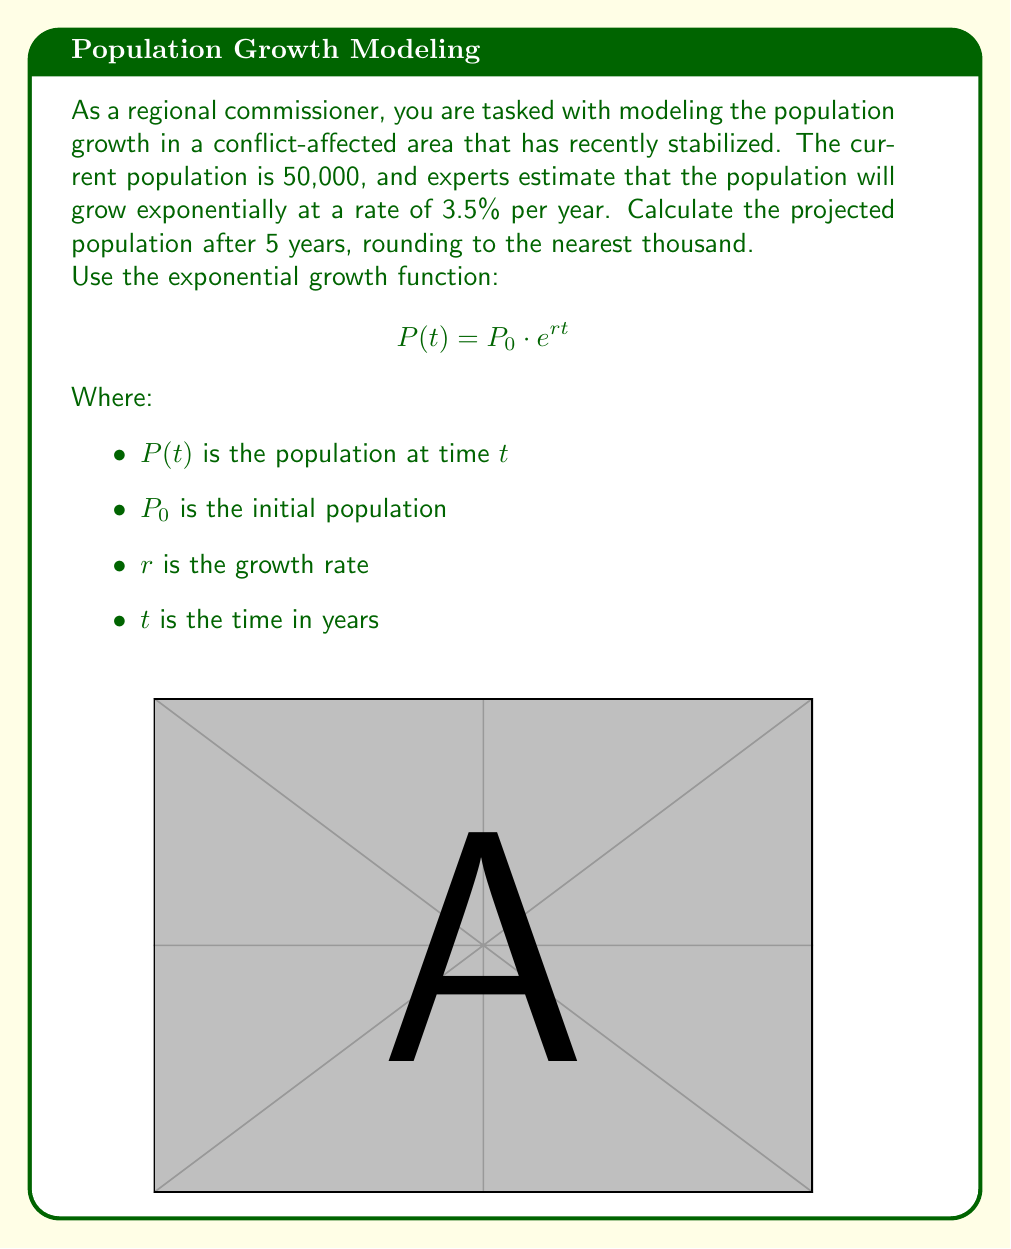Can you solve this math problem? Let's solve this step-by-step:

1) We are given:
   $P_0 = 50,000$ (initial population)
   $r = 3.5\% = 0.035$ (growth rate)
   $t = 5$ years

2) We'll use the exponential growth function:
   $$P(t) = P_0 \cdot e^{rt}$$

3) Substituting our values:
   $$P(5) = 50,000 \cdot e^{0.035 \cdot 5}$$

4) Simplify the exponent:
   $$P(5) = 50,000 \cdot e^{0.175}$$

5) Calculate $e^{0.175}$:
   $$e^{0.175} \approx 1.1912$$

6) Multiply:
   $$P(5) = 50,000 \cdot 1.1912 = 59,560$$

7) Round to the nearest thousand:
   $$P(5) \approx 60,000$$

Therefore, the projected population after 5 years is approximately 60,000.
Answer: 60,000 